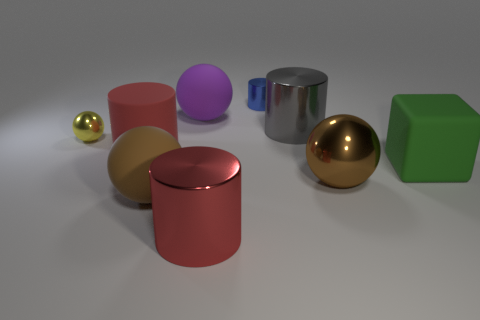The thing that is both to the right of the tiny blue shiny cylinder and left of the big brown shiny sphere is made of what material?
Make the answer very short. Metal. There is a large gray shiny cylinder that is in front of the purple rubber object; is there a brown metal object that is behind it?
Your answer should be very brief. No. There is a ball that is behind the large rubber cube and left of the purple matte thing; how big is it?
Your response must be concise. Small. How many brown objects are big shiny cylinders or small spheres?
Offer a very short reply. 0. There is a purple matte thing that is the same size as the block; what shape is it?
Make the answer very short. Sphere. What number of other objects are there of the same color as the big block?
Your response must be concise. 0. There is a object that is left of the big red cylinder on the left side of the red metal cylinder; what is its size?
Your answer should be compact. Small. Is the large red cylinder that is on the right side of the purple matte object made of the same material as the tiny cylinder?
Ensure brevity in your answer.  Yes. What is the shape of the large matte thing that is behind the red matte cylinder?
Offer a very short reply. Sphere. How many red metallic cylinders are the same size as the green matte thing?
Make the answer very short. 1. 